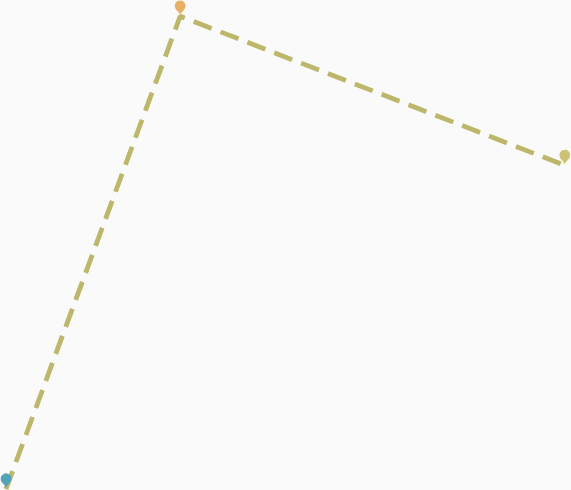<chart> <loc_0><loc_0><loc_500><loc_500><line_chart><ecel><fcel>Unnamed: 1<nl><fcel>2108.66<fcel>791.5<nl><fcel>2148.76<fcel>2022.87<nl><fcel>2237.3<fcel>1634.44<nl><fcel>2403.34<fcel>2847.4<nl></chart> 